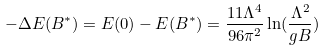<formula> <loc_0><loc_0><loc_500><loc_500>- \Delta E ( B ^ { * } ) = E ( 0 ) - E ( B ^ { * } ) = \frac { 1 1 \Lambda ^ { 4 } } { 9 6 \pi ^ { 2 } } \ln ( \frac { \Lambda ^ { 2 } } { g B } )</formula> 